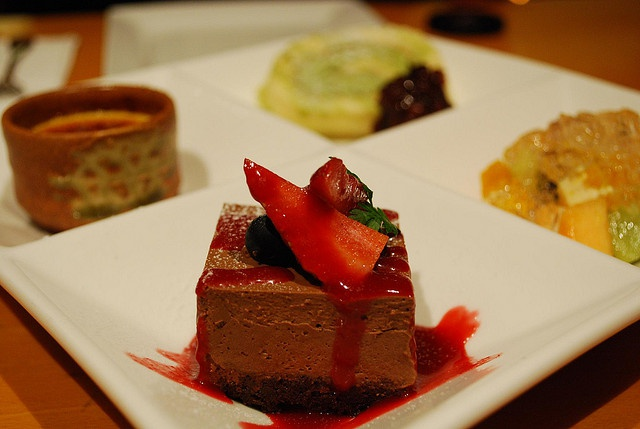Describe the objects in this image and their specific colors. I can see cake in black, maroon, and brown tones, dining table in black, maroon, and brown tones, cup in black, maroon, and brown tones, bowl in black, maroon, and brown tones, and cake in black, olive, and tan tones in this image. 